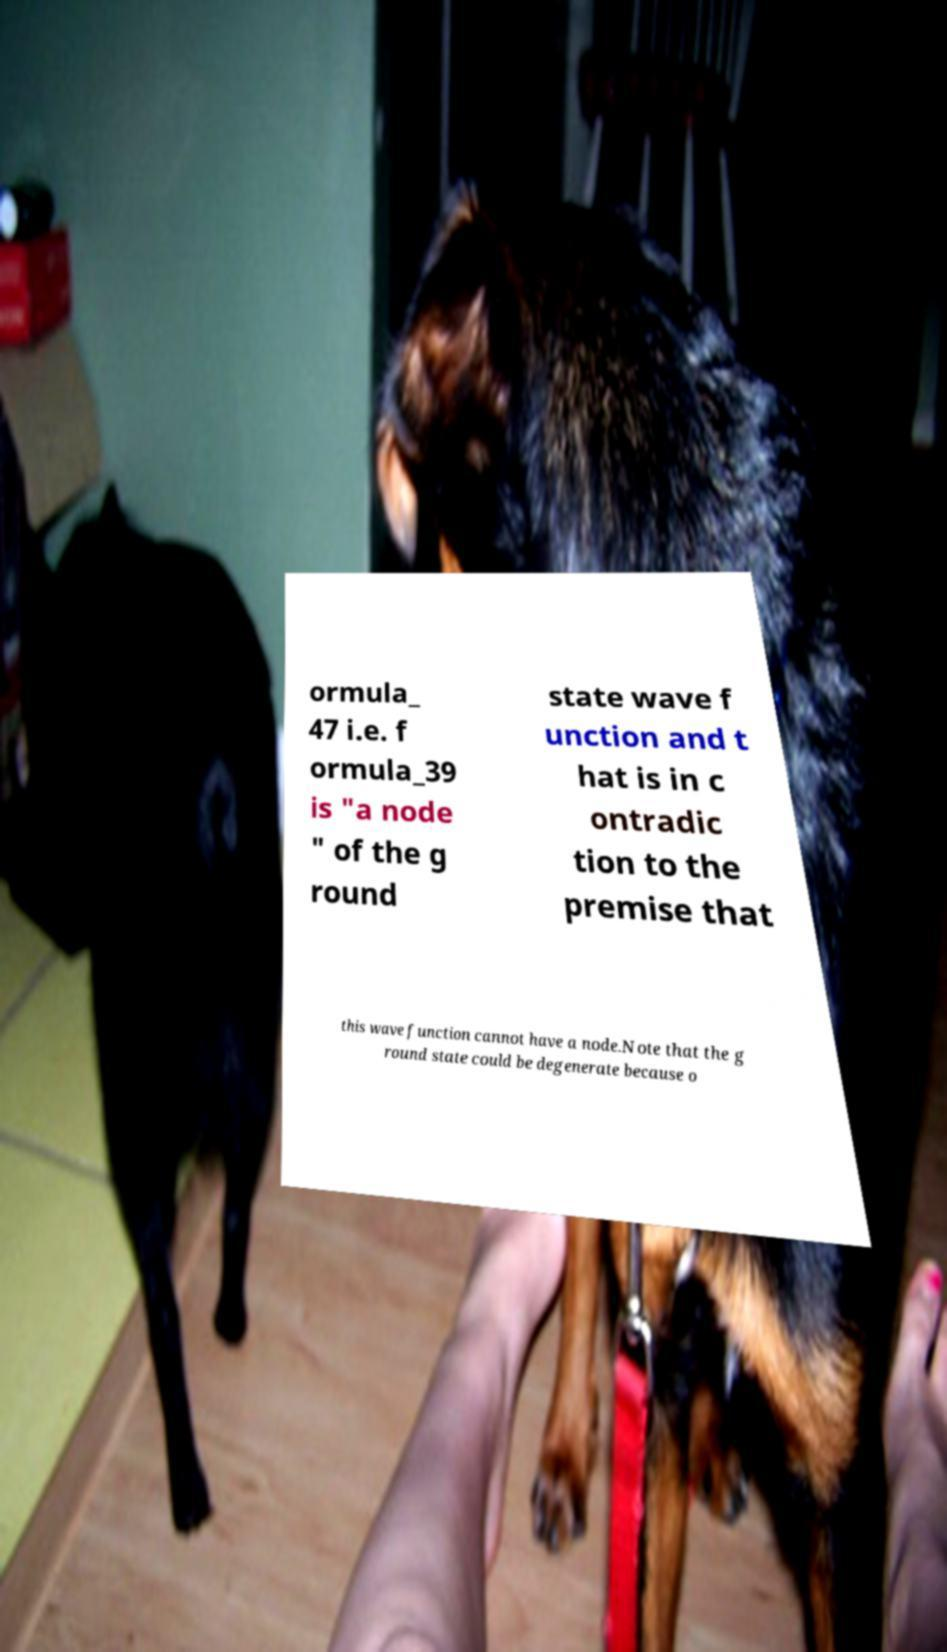What messages or text are displayed in this image? I need them in a readable, typed format. ormula_ 47 i.e. f ormula_39 is "a node " of the g round state wave f unction and t hat is in c ontradic tion to the premise that this wave function cannot have a node.Note that the g round state could be degenerate because o 